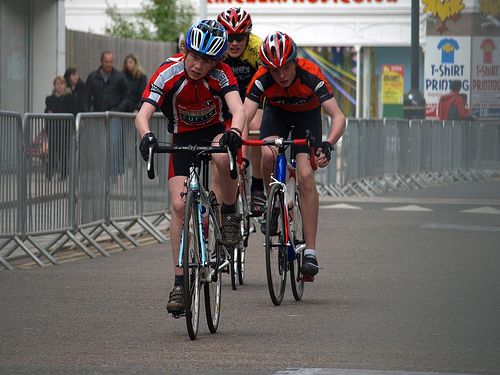<image>
Can you confirm if the helmet is on the man? No. The helmet is not positioned on the man. They may be near each other, but the helmet is not supported by or resting on top of the man. Is the person next to the person? Yes. The person is positioned adjacent to the person, located nearby in the same general area. 